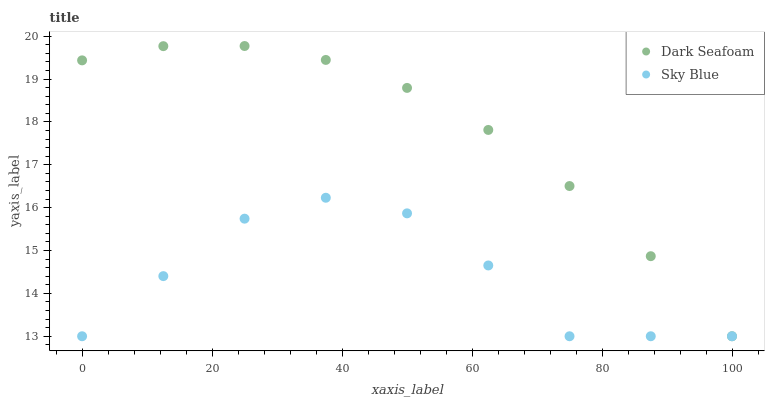Does Sky Blue have the minimum area under the curve?
Answer yes or no. Yes. Does Dark Seafoam have the maximum area under the curve?
Answer yes or no. Yes. Does Dark Seafoam have the minimum area under the curve?
Answer yes or no. No. Is Dark Seafoam the smoothest?
Answer yes or no. Yes. Is Sky Blue the roughest?
Answer yes or no. Yes. Is Dark Seafoam the roughest?
Answer yes or no. No. Does Sky Blue have the lowest value?
Answer yes or no. Yes. Does Dark Seafoam have the highest value?
Answer yes or no. Yes. Does Dark Seafoam intersect Sky Blue?
Answer yes or no. Yes. Is Dark Seafoam less than Sky Blue?
Answer yes or no. No. Is Dark Seafoam greater than Sky Blue?
Answer yes or no. No. 